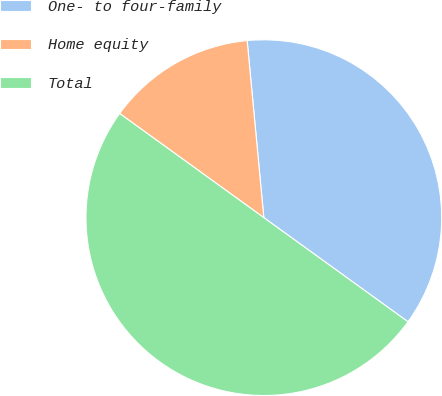Convert chart. <chart><loc_0><loc_0><loc_500><loc_500><pie_chart><fcel>One- to four-family<fcel>Home equity<fcel>Total<nl><fcel>36.45%<fcel>13.55%<fcel>50.0%<nl></chart> 